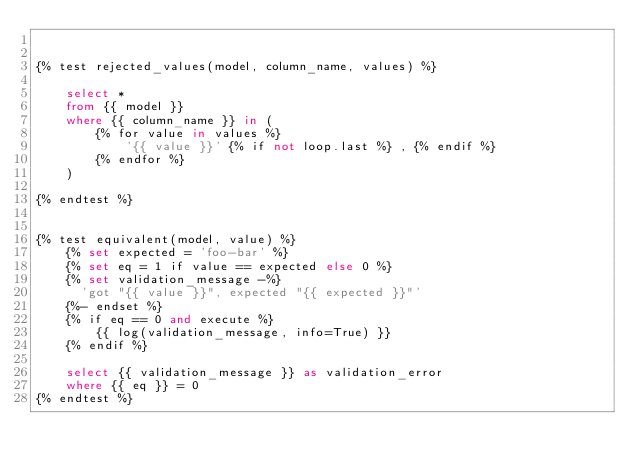<code> <loc_0><loc_0><loc_500><loc_500><_SQL_>

{% test rejected_values(model, column_name, values) %}

    select *
    from {{ model }}
    where {{ column_name }} in (
        {% for value in values %}
            '{{ value }}' {% if not loop.last %} , {% endif %}
        {% endfor %}
    )

{% endtest %}


{% test equivalent(model, value) %}
    {% set expected = 'foo-bar' %}
    {% set eq = 1 if value == expected else 0 %}
    {% set validation_message -%}
      'got "{{ value }}", expected "{{ expected }}"'
    {%- endset %}
    {% if eq == 0 and execute %}
        {{ log(validation_message, info=True) }}
    {% endif %}

    select {{ validation_message }} as validation_error
    where {{ eq }} = 0
{% endtest %}

</code> 